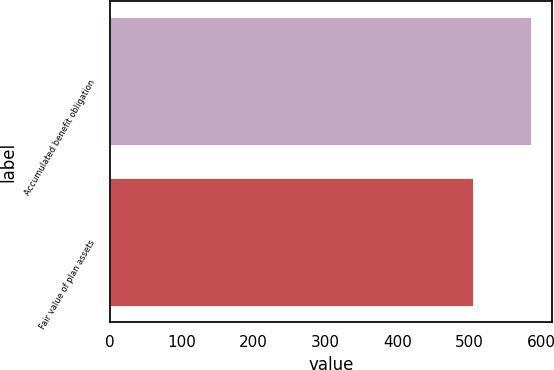Convert chart to OTSL. <chart><loc_0><loc_0><loc_500><loc_500><bar_chart><fcel>Accumulated benefit obligation<fcel>Fair value of plan assets<nl><fcel>585.9<fcel>505.7<nl></chart> 